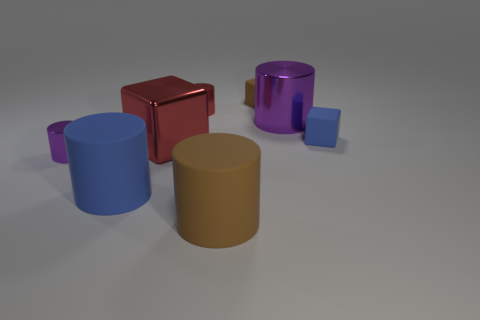Subtract all blue cubes. How many cubes are left? 2 Add 2 large shiny cylinders. How many objects exist? 10 Subtract all purple cubes. How many purple cylinders are left? 2 Subtract all purple cylinders. How many cylinders are left? 3 Subtract all green blocks. Subtract all cyan balls. How many blocks are left? 3 Subtract all blue matte things. Subtract all red objects. How many objects are left? 4 Add 8 big blue cylinders. How many big blue cylinders are left? 9 Add 3 matte objects. How many matte objects exist? 7 Subtract 0 purple spheres. How many objects are left? 8 Subtract all cylinders. How many objects are left? 3 